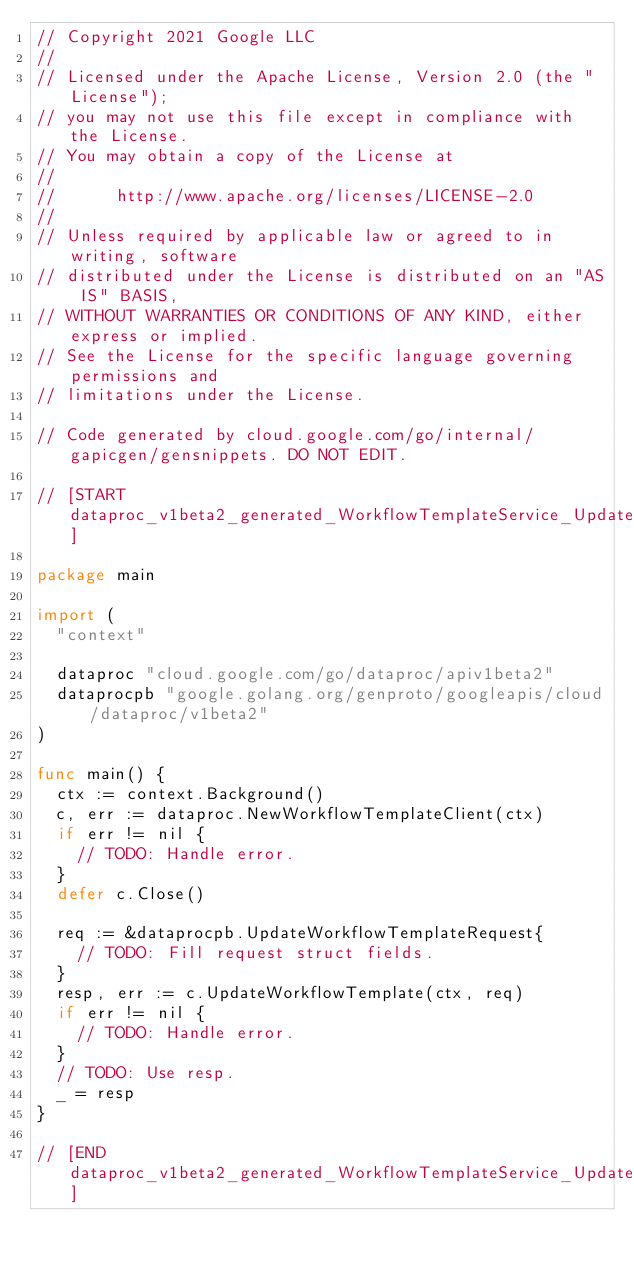Convert code to text. <code><loc_0><loc_0><loc_500><loc_500><_Go_>// Copyright 2021 Google LLC
//
// Licensed under the Apache License, Version 2.0 (the "License");
// you may not use this file except in compliance with the License.
// You may obtain a copy of the License at
//
//      http://www.apache.org/licenses/LICENSE-2.0
//
// Unless required by applicable law or agreed to in writing, software
// distributed under the License is distributed on an "AS IS" BASIS,
// WITHOUT WARRANTIES OR CONDITIONS OF ANY KIND, either express or implied.
// See the License for the specific language governing permissions and
// limitations under the License.

// Code generated by cloud.google.com/go/internal/gapicgen/gensnippets. DO NOT EDIT.

// [START dataproc_v1beta2_generated_WorkflowTemplateService_UpdateWorkflowTemplate_sync]

package main

import (
	"context"

	dataproc "cloud.google.com/go/dataproc/apiv1beta2"
	dataprocpb "google.golang.org/genproto/googleapis/cloud/dataproc/v1beta2"
)

func main() {
	ctx := context.Background()
	c, err := dataproc.NewWorkflowTemplateClient(ctx)
	if err != nil {
		// TODO: Handle error.
	}
	defer c.Close()

	req := &dataprocpb.UpdateWorkflowTemplateRequest{
		// TODO: Fill request struct fields.
	}
	resp, err := c.UpdateWorkflowTemplate(ctx, req)
	if err != nil {
		// TODO: Handle error.
	}
	// TODO: Use resp.
	_ = resp
}

// [END dataproc_v1beta2_generated_WorkflowTemplateService_UpdateWorkflowTemplate_sync]
</code> 